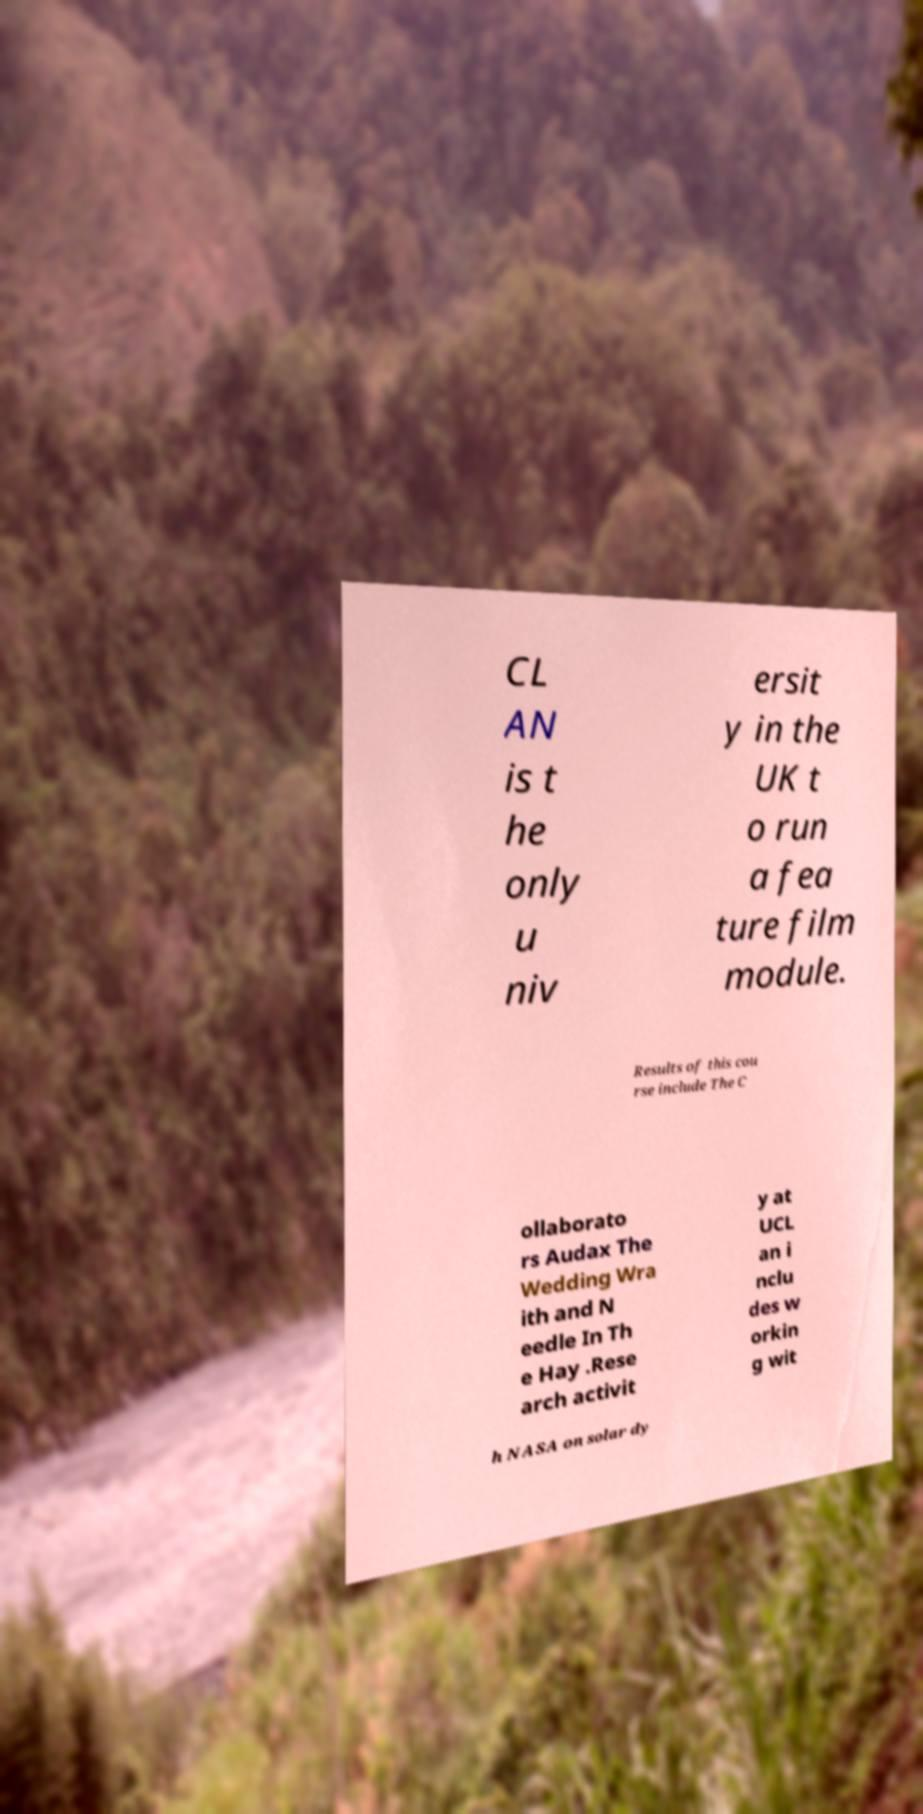Please identify and transcribe the text found in this image. CL AN is t he only u niv ersit y in the UK t o run a fea ture film module. Results of this cou rse include The C ollaborato rs Audax The Wedding Wra ith and N eedle In Th e Hay .Rese arch activit y at UCL an i nclu des w orkin g wit h NASA on solar dy 